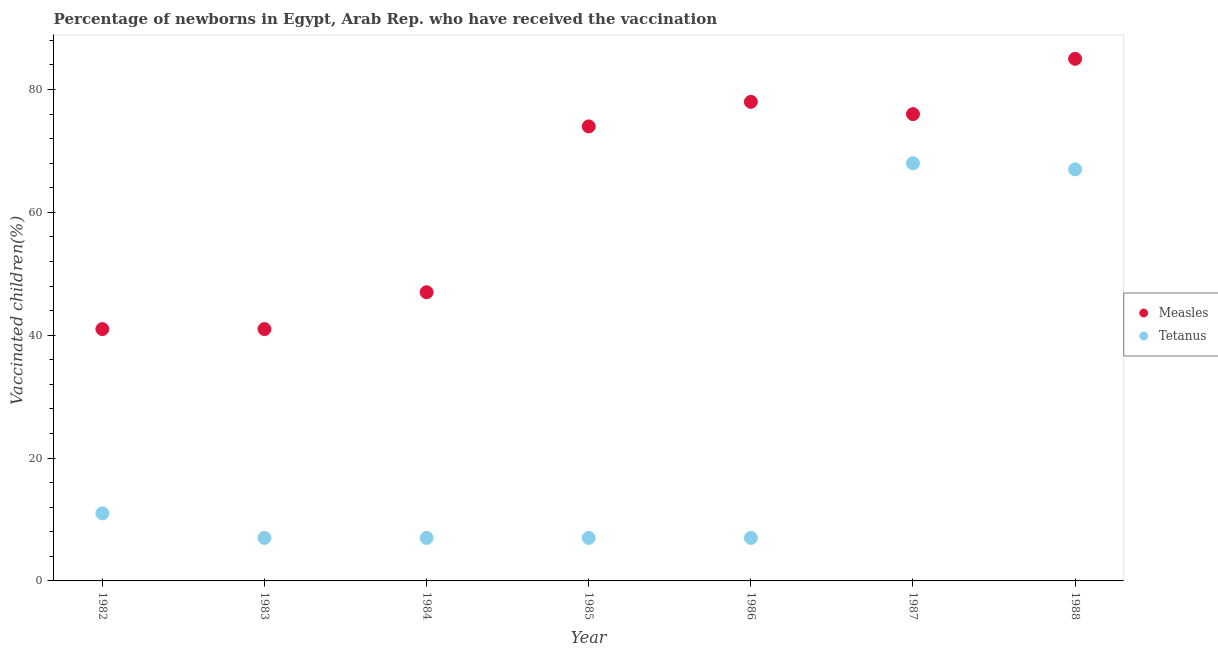How many different coloured dotlines are there?
Offer a very short reply. 2. Is the number of dotlines equal to the number of legend labels?
Your response must be concise. Yes. What is the percentage of newborns who received vaccination for measles in 1982?
Offer a very short reply. 41. Across all years, what is the maximum percentage of newborns who received vaccination for measles?
Make the answer very short. 85. Across all years, what is the minimum percentage of newborns who received vaccination for tetanus?
Offer a very short reply. 7. What is the total percentage of newborns who received vaccination for tetanus in the graph?
Provide a short and direct response. 174. What is the difference between the percentage of newborns who received vaccination for measles in 1984 and that in 1987?
Give a very brief answer. -29. What is the difference between the percentage of newborns who received vaccination for measles in 1982 and the percentage of newborns who received vaccination for tetanus in 1988?
Keep it short and to the point. -26. What is the average percentage of newborns who received vaccination for tetanus per year?
Your response must be concise. 24.86. In the year 1984, what is the difference between the percentage of newborns who received vaccination for tetanus and percentage of newborns who received vaccination for measles?
Your response must be concise. -40. What is the ratio of the percentage of newborns who received vaccination for measles in 1982 to that in 1988?
Give a very brief answer. 0.48. Is the percentage of newborns who received vaccination for measles in 1984 less than that in 1988?
Your answer should be very brief. Yes. Is the difference between the percentage of newborns who received vaccination for measles in 1984 and 1987 greater than the difference between the percentage of newborns who received vaccination for tetanus in 1984 and 1987?
Your answer should be compact. Yes. What is the difference between the highest and the lowest percentage of newborns who received vaccination for measles?
Keep it short and to the point. 44. In how many years, is the percentage of newborns who received vaccination for tetanus greater than the average percentage of newborns who received vaccination for tetanus taken over all years?
Give a very brief answer. 2. Does the percentage of newborns who received vaccination for tetanus monotonically increase over the years?
Your answer should be very brief. No. Is the percentage of newborns who received vaccination for tetanus strictly less than the percentage of newborns who received vaccination for measles over the years?
Provide a succinct answer. Yes. How many dotlines are there?
Give a very brief answer. 2. What is the difference between two consecutive major ticks on the Y-axis?
Provide a short and direct response. 20. Are the values on the major ticks of Y-axis written in scientific E-notation?
Give a very brief answer. No. Does the graph contain any zero values?
Your answer should be compact. No. How are the legend labels stacked?
Ensure brevity in your answer.  Vertical. What is the title of the graph?
Ensure brevity in your answer.  Percentage of newborns in Egypt, Arab Rep. who have received the vaccination. What is the label or title of the Y-axis?
Offer a terse response. Vaccinated children(%)
. What is the Vaccinated children(%)
 in Measles in 1982?
Provide a succinct answer. 41. What is the Vaccinated children(%)
 in Measles in 1983?
Offer a very short reply. 41. What is the Vaccinated children(%)
 of Tetanus in 1983?
Your answer should be very brief. 7. What is the Vaccinated children(%)
 of Tetanus in 1985?
Keep it short and to the point. 7. What is the Vaccinated children(%)
 of Measles in 1986?
Provide a short and direct response. 78. What is the Vaccinated children(%)
 in Measles in 1988?
Ensure brevity in your answer.  85. What is the Vaccinated children(%)
 of Tetanus in 1988?
Your answer should be compact. 67. Across all years, what is the maximum Vaccinated children(%)
 in Measles?
Make the answer very short. 85. Across all years, what is the maximum Vaccinated children(%)
 of Tetanus?
Your answer should be very brief. 68. Across all years, what is the minimum Vaccinated children(%)
 of Tetanus?
Offer a very short reply. 7. What is the total Vaccinated children(%)
 in Measles in the graph?
Provide a succinct answer. 442. What is the total Vaccinated children(%)
 of Tetanus in the graph?
Offer a very short reply. 174. What is the difference between the Vaccinated children(%)
 of Measles in 1982 and that in 1983?
Offer a very short reply. 0. What is the difference between the Vaccinated children(%)
 in Tetanus in 1982 and that in 1983?
Your response must be concise. 4. What is the difference between the Vaccinated children(%)
 in Tetanus in 1982 and that in 1984?
Your answer should be very brief. 4. What is the difference between the Vaccinated children(%)
 in Measles in 1982 and that in 1985?
Keep it short and to the point. -33. What is the difference between the Vaccinated children(%)
 of Tetanus in 1982 and that in 1985?
Offer a very short reply. 4. What is the difference between the Vaccinated children(%)
 in Measles in 1982 and that in 1986?
Your response must be concise. -37. What is the difference between the Vaccinated children(%)
 of Tetanus in 1982 and that in 1986?
Your response must be concise. 4. What is the difference between the Vaccinated children(%)
 of Measles in 1982 and that in 1987?
Offer a terse response. -35. What is the difference between the Vaccinated children(%)
 of Tetanus in 1982 and that in 1987?
Offer a very short reply. -57. What is the difference between the Vaccinated children(%)
 in Measles in 1982 and that in 1988?
Provide a short and direct response. -44. What is the difference between the Vaccinated children(%)
 in Tetanus in 1982 and that in 1988?
Give a very brief answer. -56. What is the difference between the Vaccinated children(%)
 of Tetanus in 1983 and that in 1984?
Offer a terse response. 0. What is the difference between the Vaccinated children(%)
 in Measles in 1983 and that in 1985?
Offer a terse response. -33. What is the difference between the Vaccinated children(%)
 of Tetanus in 1983 and that in 1985?
Provide a succinct answer. 0. What is the difference between the Vaccinated children(%)
 of Measles in 1983 and that in 1986?
Offer a terse response. -37. What is the difference between the Vaccinated children(%)
 of Tetanus in 1983 and that in 1986?
Make the answer very short. 0. What is the difference between the Vaccinated children(%)
 in Measles in 1983 and that in 1987?
Offer a terse response. -35. What is the difference between the Vaccinated children(%)
 of Tetanus in 1983 and that in 1987?
Offer a terse response. -61. What is the difference between the Vaccinated children(%)
 of Measles in 1983 and that in 1988?
Offer a terse response. -44. What is the difference between the Vaccinated children(%)
 of Tetanus in 1983 and that in 1988?
Offer a very short reply. -60. What is the difference between the Vaccinated children(%)
 of Measles in 1984 and that in 1985?
Keep it short and to the point. -27. What is the difference between the Vaccinated children(%)
 of Tetanus in 1984 and that in 1985?
Offer a terse response. 0. What is the difference between the Vaccinated children(%)
 of Measles in 1984 and that in 1986?
Keep it short and to the point. -31. What is the difference between the Vaccinated children(%)
 in Tetanus in 1984 and that in 1986?
Provide a succinct answer. 0. What is the difference between the Vaccinated children(%)
 in Measles in 1984 and that in 1987?
Your response must be concise. -29. What is the difference between the Vaccinated children(%)
 in Tetanus in 1984 and that in 1987?
Provide a succinct answer. -61. What is the difference between the Vaccinated children(%)
 in Measles in 1984 and that in 1988?
Offer a very short reply. -38. What is the difference between the Vaccinated children(%)
 in Tetanus in 1984 and that in 1988?
Provide a short and direct response. -60. What is the difference between the Vaccinated children(%)
 in Measles in 1985 and that in 1986?
Make the answer very short. -4. What is the difference between the Vaccinated children(%)
 in Tetanus in 1985 and that in 1987?
Offer a terse response. -61. What is the difference between the Vaccinated children(%)
 of Measles in 1985 and that in 1988?
Give a very brief answer. -11. What is the difference between the Vaccinated children(%)
 of Tetanus in 1985 and that in 1988?
Offer a very short reply. -60. What is the difference between the Vaccinated children(%)
 of Measles in 1986 and that in 1987?
Offer a terse response. 2. What is the difference between the Vaccinated children(%)
 of Tetanus in 1986 and that in 1987?
Offer a very short reply. -61. What is the difference between the Vaccinated children(%)
 of Tetanus in 1986 and that in 1988?
Offer a very short reply. -60. What is the difference between the Vaccinated children(%)
 of Tetanus in 1987 and that in 1988?
Offer a terse response. 1. What is the difference between the Vaccinated children(%)
 of Measles in 1982 and the Vaccinated children(%)
 of Tetanus in 1985?
Offer a very short reply. 34. What is the difference between the Vaccinated children(%)
 in Measles in 1982 and the Vaccinated children(%)
 in Tetanus in 1986?
Your answer should be very brief. 34. What is the difference between the Vaccinated children(%)
 of Measles in 1982 and the Vaccinated children(%)
 of Tetanus in 1988?
Ensure brevity in your answer.  -26. What is the difference between the Vaccinated children(%)
 in Measles in 1983 and the Vaccinated children(%)
 in Tetanus in 1988?
Ensure brevity in your answer.  -26. What is the difference between the Vaccinated children(%)
 of Measles in 1984 and the Vaccinated children(%)
 of Tetanus in 1988?
Give a very brief answer. -20. What is the difference between the Vaccinated children(%)
 of Measles in 1985 and the Vaccinated children(%)
 of Tetanus in 1988?
Ensure brevity in your answer.  7. What is the difference between the Vaccinated children(%)
 in Measles in 1987 and the Vaccinated children(%)
 in Tetanus in 1988?
Give a very brief answer. 9. What is the average Vaccinated children(%)
 of Measles per year?
Keep it short and to the point. 63.14. What is the average Vaccinated children(%)
 in Tetanus per year?
Give a very brief answer. 24.86. In the year 1983, what is the difference between the Vaccinated children(%)
 in Measles and Vaccinated children(%)
 in Tetanus?
Your answer should be compact. 34. In the year 1985, what is the difference between the Vaccinated children(%)
 of Measles and Vaccinated children(%)
 of Tetanus?
Offer a very short reply. 67. In the year 1986, what is the difference between the Vaccinated children(%)
 of Measles and Vaccinated children(%)
 of Tetanus?
Keep it short and to the point. 71. What is the ratio of the Vaccinated children(%)
 of Measles in 1982 to that in 1983?
Your answer should be compact. 1. What is the ratio of the Vaccinated children(%)
 in Tetanus in 1982 to that in 1983?
Make the answer very short. 1.57. What is the ratio of the Vaccinated children(%)
 in Measles in 1982 to that in 1984?
Give a very brief answer. 0.87. What is the ratio of the Vaccinated children(%)
 of Tetanus in 1982 to that in 1984?
Provide a short and direct response. 1.57. What is the ratio of the Vaccinated children(%)
 in Measles in 1982 to that in 1985?
Provide a short and direct response. 0.55. What is the ratio of the Vaccinated children(%)
 in Tetanus in 1982 to that in 1985?
Your answer should be very brief. 1.57. What is the ratio of the Vaccinated children(%)
 in Measles in 1982 to that in 1986?
Your response must be concise. 0.53. What is the ratio of the Vaccinated children(%)
 of Tetanus in 1982 to that in 1986?
Give a very brief answer. 1.57. What is the ratio of the Vaccinated children(%)
 of Measles in 1982 to that in 1987?
Give a very brief answer. 0.54. What is the ratio of the Vaccinated children(%)
 of Tetanus in 1982 to that in 1987?
Your answer should be very brief. 0.16. What is the ratio of the Vaccinated children(%)
 in Measles in 1982 to that in 1988?
Provide a short and direct response. 0.48. What is the ratio of the Vaccinated children(%)
 of Tetanus in 1982 to that in 1988?
Make the answer very short. 0.16. What is the ratio of the Vaccinated children(%)
 in Measles in 1983 to that in 1984?
Offer a terse response. 0.87. What is the ratio of the Vaccinated children(%)
 in Measles in 1983 to that in 1985?
Keep it short and to the point. 0.55. What is the ratio of the Vaccinated children(%)
 of Measles in 1983 to that in 1986?
Offer a very short reply. 0.53. What is the ratio of the Vaccinated children(%)
 in Tetanus in 1983 to that in 1986?
Offer a terse response. 1. What is the ratio of the Vaccinated children(%)
 of Measles in 1983 to that in 1987?
Your response must be concise. 0.54. What is the ratio of the Vaccinated children(%)
 in Tetanus in 1983 to that in 1987?
Provide a short and direct response. 0.1. What is the ratio of the Vaccinated children(%)
 of Measles in 1983 to that in 1988?
Offer a very short reply. 0.48. What is the ratio of the Vaccinated children(%)
 in Tetanus in 1983 to that in 1988?
Offer a terse response. 0.1. What is the ratio of the Vaccinated children(%)
 of Measles in 1984 to that in 1985?
Your answer should be compact. 0.64. What is the ratio of the Vaccinated children(%)
 of Measles in 1984 to that in 1986?
Offer a terse response. 0.6. What is the ratio of the Vaccinated children(%)
 in Measles in 1984 to that in 1987?
Your answer should be compact. 0.62. What is the ratio of the Vaccinated children(%)
 of Tetanus in 1984 to that in 1987?
Provide a succinct answer. 0.1. What is the ratio of the Vaccinated children(%)
 in Measles in 1984 to that in 1988?
Offer a very short reply. 0.55. What is the ratio of the Vaccinated children(%)
 in Tetanus in 1984 to that in 1988?
Offer a terse response. 0.1. What is the ratio of the Vaccinated children(%)
 of Measles in 1985 to that in 1986?
Keep it short and to the point. 0.95. What is the ratio of the Vaccinated children(%)
 of Tetanus in 1985 to that in 1986?
Your answer should be compact. 1. What is the ratio of the Vaccinated children(%)
 in Measles in 1985 to that in 1987?
Keep it short and to the point. 0.97. What is the ratio of the Vaccinated children(%)
 of Tetanus in 1985 to that in 1987?
Offer a terse response. 0.1. What is the ratio of the Vaccinated children(%)
 in Measles in 1985 to that in 1988?
Ensure brevity in your answer.  0.87. What is the ratio of the Vaccinated children(%)
 of Tetanus in 1985 to that in 1988?
Offer a terse response. 0.1. What is the ratio of the Vaccinated children(%)
 in Measles in 1986 to that in 1987?
Provide a short and direct response. 1.03. What is the ratio of the Vaccinated children(%)
 of Tetanus in 1986 to that in 1987?
Offer a very short reply. 0.1. What is the ratio of the Vaccinated children(%)
 of Measles in 1986 to that in 1988?
Make the answer very short. 0.92. What is the ratio of the Vaccinated children(%)
 of Tetanus in 1986 to that in 1988?
Your answer should be compact. 0.1. What is the ratio of the Vaccinated children(%)
 of Measles in 1987 to that in 1988?
Ensure brevity in your answer.  0.89. What is the ratio of the Vaccinated children(%)
 in Tetanus in 1987 to that in 1988?
Your response must be concise. 1.01. What is the difference between the highest and the second highest Vaccinated children(%)
 in Measles?
Your answer should be very brief. 7. What is the difference between the highest and the second highest Vaccinated children(%)
 in Tetanus?
Provide a short and direct response. 1. What is the difference between the highest and the lowest Vaccinated children(%)
 of Measles?
Provide a succinct answer. 44. 